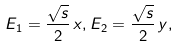<formula> <loc_0><loc_0><loc_500><loc_500>E _ { 1 } = \frac { \sqrt { s } } { 2 } \, x , E _ { 2 } = \frac { \sqrt { s } } { 2 } \, y ,</formula> 